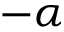Convert formula to latex. <formula><loc_0><loc_0><loc_500><loc_500>- \alpha</formula> 